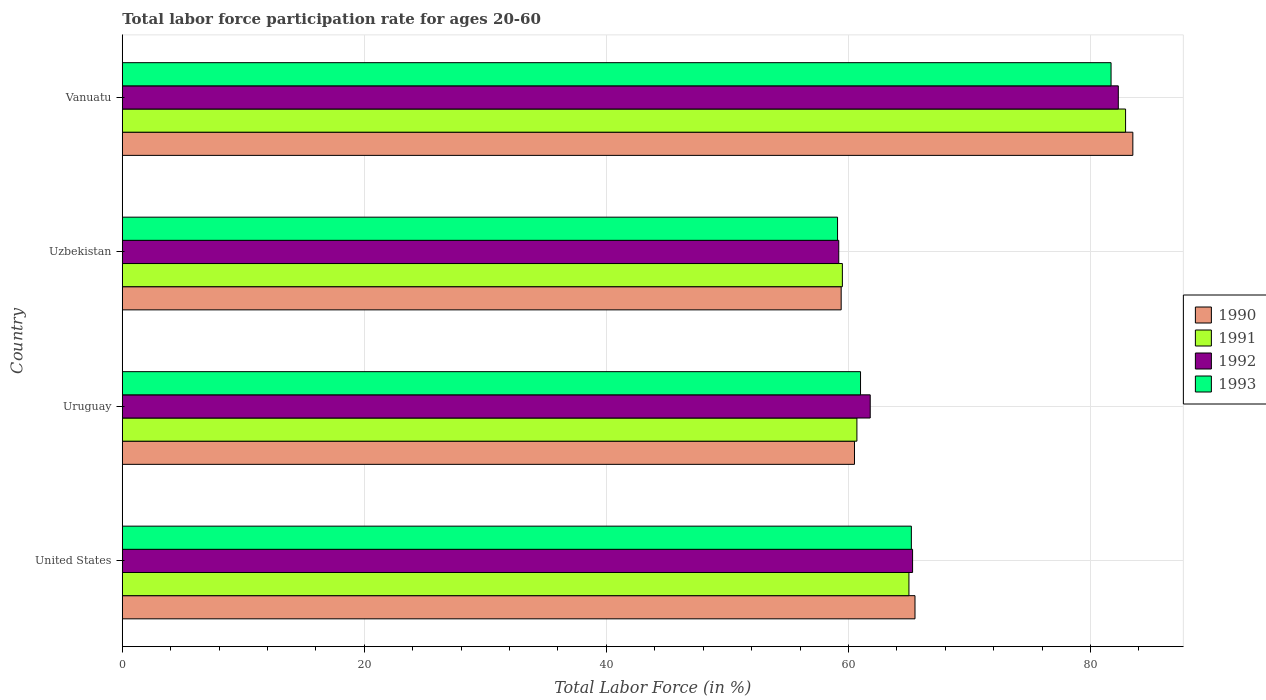How many different coloured bars are there?
Your answer should be compact. 4. Are the number of bars on each tick of the Y-axis equal?
Provide a short and direct response. Yes. How many bars are there on the 4th tick from the bottom?
Provide a short and direct response. 4. What is the label of the 3rd group of bars from the top?
Your answer should be compact. Uruguay. What is the labor force participation rate in 1992 in Vanuatu?
Your answer should be compact. 82.3. Across all countries, what is the maximum labor force participation rate in 1991?
Your answer should be very brief. 82.9. Across all countries, what is the minimum labor force participation rate in 1992?
Your answer should be very brief. 59.2. In which country was the labor force participation rate in 1991 maximum?
Your answer should be very brief. Vanuatu. In which country was the labor force participation rate in 1991 minimum?
Give a very brief answer. Uzbekistan. What is the total labor force participation rate in 1993 in the graph?
Your answer should be very brief. 267. What is the difference between the labor force participation rate in 1992 in United States and that in Uruguay?
Give a very brief answer. 3.5. What is the difference between the labor force participation rate in 1990 in Uzbekistan and the labor force participation rate in 1992 in Uruguay?
Your response must be concise. -2.4. What is the average labor force participation rate in 1991 per country?
Keep it short and to the point. 67.03. What is the difference between the labor force participation rate in 1993 and labor force participation rate in 1991 in Vanuatu?
Give a very brief answer. -1.2. In how many countries, is the labor force participation rate in 1993 greater than 36 %?
Give a very brief answer. 4. What is the ratio of the labor force participation rate in 1992 in United States to that in Vanuatu?
Offer a terse response. 0.79. What is the difference between the highest and the second highest labor force participation rate in 1993?
Provide a short and direct response. 16.5. What is the difference between the highest and the lowest labor force participation rate in 1990?
Make the answer very short. 24.1. Is it the case that in every country, the sum of the labor force participation rate in 1992 and labor force participation rate in 1993 is greater than the sum of labor force participation rate in 1990 and labor force participation rate in 1991?
Your answer should be very brief. No. What does the 2nd bar from the bottom in Uzbekistan represents?
Offer a very short reply. 1991. Is it the case that in every country, the sum of the labor force participation rate in 1993 and labor force participation rate in 1991 is greater than the labor force participation rate in 1990?
Give a very brief answer. Yes. How many bars are there?
Offer a very short reply. 16. How many countries are there in the graph?
Keep it short and to the point. 4. What is the difference between two consecutive major ticks on the X-axis?
Provide a succinct answer. 20. Are the values on the major ticks of X-axis written in scientific E-notation?
Your answer should be very brief. No. Does the graph contain grids?
Your answer should be very brief. Yes. How are the legend labels stacked?
Provide a short and direct response. Vertical. What is the title of the graph?
Your answer should be compact. Total labor force participation rate for ages 20-60. Does "1963" appear as one of the legend labels in the graph?
Ensure brevity in your answer.  No. What is the Total Labor Force (in %) of 1990 in United States?
Keep it short and to the point. 65.5. What is the Total Labor Force (in %) of 1992 in United States?
Ensure brevity in your answer.  65.3. What is the Total Labor Force (in %) of 1993 in United States?
Give a very brief answer. 65.2. What is the Total Labor Force (in %) in 1990 in Uruguay?
Make the answer very short. 60.5. What is the Total Labor Force (in %) in 1991 in Uruguay?
Give a very brief answer. 60.7. What is the Total Labor Force (in %) of 1992 in Uruguay?
Give a very brief answer. 61.8. What is the Total Labor Force (in %) of 1993 in Uruguay?
Your answer should be compact. 61. What is the Total Labor Force (in %) in 1990 in Uzbekistan?
Provide a succinct answer. 59.4. What is the Total Labor Force (in %) of 1991 in Uzbekistan?
Ensure brevity in your answer.  59.5. What is the Total Labor Force (in %) in 1992 in Uzbekistan?
Give a very brief answer. 59.2. What is the Total Labor Force (in %) in 1993 in Uzbekistan?
Provide a succinct answer. 59.1. What is the Total Labor Force (in %) in 1990 in Vanuatu?
Your answer should be compact. 83.5. What is the Total Labor Force (in %) in 1991 in Vanuatu?
Make the answer very short. 82.9. What is the Total Labor Force (in %) in 1992 in Vanuatu?
Provide a succinct answer. 82.3. What is the Total Labor Force (in %) in 1993 in Vanuatu?
Give a very brief answer. 81.7. Across all countries, what is the maximum Total Labor Force (in %) of 1990?
Your answer should be very brief. 83.5. Across all countries, what is the maximum Total Labor Force (in %) in 1991?
Provide a succinct answer. 82.9. Across all countries, what is the maximum Total Labor Force (in %) of 1992?
Your response must be concise. 82.3. Across all countries, what is the maximum Total Labor Force (in %) in 1993?
Make the answer very short. 81.7. Across all countries, what is the minimum Total Labor Force (in %) in 1990?
Offer a terse response. 59.4. Across all countries, what is the minimum Total Labor Force (in %) in 1991?
Ensure brevity in your answer.  59.5. Across all countries, what is the minimum Total Labor Force (in %) of 1992?
Offer a terse response. 59.2. Across all countries, what is the minimum Total Labor Force (in %) of 1993?
Your response must be concise. 59.1. What is the total Total Labor Force (in %) of 1990 in the graph?
Provide a short and direct response. 268.9. What is the total Total Labor Force (in %) of 1991 in the graph?
Offer a very short reply. 268.1. What is the total Total Labor Force (in %) of 1992 in the graph?
Provide a short and direct response. 268.6. What is the total Total Labor Force (in %) of 1993 in the graph?
Ensure brevity in your answer.  267. What is the difference between the Total Labor Force (in %) of 1993 in United States and that in Uruguay?
Give a very brief answer. 4.2. What is the difference between the Total Labor Force (in %) of 1991 in United States and that in Uzbekistan?
Keep it short and to the point. 5.5. What is the difference between the Total Labor Force (in %) of 1992 in United States and that in Uzbekistan?
Offer a very short reply. 6.1. What is the difference between the Total Labor Force (in %) in 1993 in United States and that in Uzbekistan?
Offer a very short reply. 6.1. What is the difference between the Total Labor Force (in %) of 1990 in United States and that in Vanuatu?
Offer a very short reply. -18. What is the difference between the Total Labor Force (in %) of 1991 in United States and that in Vanuatu?
Provide a short and direct response. -17.9. What is the difference between the Total Labor Force (in %) of 1993 in United States and that in Vanuatu?
Provide a succinct answer. -16.5. What is the difference between the Total Labor Force (in %) in 1990 in Uruguay and that in Uzbekistan?
Offer a very short reply. 1.1. What is the difference between the Total Labor Force (in %) in 1992 in Uruguay and that in Uzbekistan?
Provide a short and direct response. 2.6. What is the difference between the Total Labor Force (in %) in 1993 in Uruguay and that in Uzbekistan?
Offer a very short reply. 1.9. What is the difference between the Total Labor Force (in %) in 1990 in Uruguay and that in Vanuatu?
Your response must be concise. -23. What is the difference between the Total Labor Force (in %) of 1991 in Uruguay and that in Vanuatu?
Your answer should be compact. -22.2. What is the difference between the Total Labor Force (in %) in 1992 in Uruguay and that in Vanuatu?
Provide a succinct answer. -20.5. What is the difference between the Total Labor Force (in %) of 1993 in Uruguay and that in Vanuatu?
Offer a very short reply. -20.7. What is the difference between the Total Labor Force (in %) of 1990 in Uzbekistan and that in Vanuatu?
Keep it short and to the point. -24.1. What is the difference between the Total Labor Force (in %) of 1991 in Uzbekistan and that in Vanuatu?
Offer a very short reply. -23.4. What is the difference between the Total Labor Force (in %) in 1992 in Uzbekistan and that in Vanuatu?
Provide a succinct answer. -23.1. What is the difference between the Total Labor Force (in %) in 1993 in Uzbekistan and that in Vanuatu?
Your answer should be very brief. -22.6. What is the difference between the Total Labor Force (in %) in 1990 in United States and the Total Labor Force (in %) in 1992 in Uruguay?
Provide a short and direct response. 3.7. What is the difference between the Total Labor Force (in %) of 1991 in United States and the Total Labor Force (in %) of 1992 in Uruguay?
Offer a very short reply. 3.2. What is the difference between the Total Labor Force (in %) in 1991 in United States and the Total Labor Force (in %) in 1993 in Uruguay?
Your response must be concise. 4. What is the difference between the Total Labor Force (in %) of 1992 in United States and the Total Labor Force (in %) of 1993 in Uruguay?
Provide a short and direct response. 4.3. What is the difference between the Total Labor Force (in %) of 1990 in United States and the Total Labor Force (in %) of 1993 in Uzbekistan?
Provide a short and direct response. 6.4. What is the difference between the Total Labor Force (in %) of 1991 in United States and the Total Labor Force (in %) of 1992 in Uzbekistan?
Your answer should be very brief. 5.8. What is the difference between the Total Labor Force (in %) in 1990 in United States and the Total Labor Force (in %) in 1991 in Vanuatu?
Your response must be concise. -17.4. What is the difference between the Total Labor Force (in %) of 1990 in United States and the Total Labor Force (in %) of 1992 in Vanuatu?
Your response must be concise. -16.8. What is the difference between the Total Labor Force (in %) in 1990 in United States and the Total Labor Force (in %) in 1993 in Vanuatu?
Provide a succinct answer. -16.2. What is the difference between the Total Labor Force (in %) of 1991 in United States and the Total Labor Force (in %) of 1992 in Vanuatu?
Offer a very short reply. -17.3. What is the difference between the Total Labor Force (in %) in 1991 in United States and the Total Labor Force (in %) in 1993 in Vanuatu?
Offer a terse response. -16.7. What is the difference between the Total Labor Force (in %) in 1992 in United States and the Total Labor Force (in %) in 1993 in Vanuatu?
Provide a short and direct response. -16.4. What is the difference between the Total Labor Force (in %) in 1990 in Uruguay and the Total Labor Force (in %) in 1992 in Uzbekistan?
Ensure brevity in your answer.  1.3. What is the difference between the Total Labor Force (in %) of 1991 in Uruguay and the Total Labor Force (in %) of 1992 in Uzbekistan?
Provide a succinct answer. 1.5. What is the difference between the Total Labor Force (in %) in 1991 in Uruguay and the Total Labor Force (in %) in 1993 in Uzbekistan?
Give a very brief answer. 1.6. What is the difference between the Total Labor Force (in %) of 1992 in Uruguay and the Total Labor Force (in %) of 1993 in Uzbekistan?
Give a very brief answer. 2.7. What is the difference between the Total Labor Force (in %) of 1990 in Uruguay and the Total Labor Force (in %) of 1991 in Vanuatu?
Your answer should be compact. -22.4. What is the difference between the Total Labor Force (in %) in 1990 in Uruguay and the Total Labor Force (in %) in 1992 in Vanuatu?
Offer a terse response. -21.8. What is the difference between the Total Labor Force (in %) in 1990 in Uruguay and the Total Labor Force (in %) in 1993 in Vanuatu?
Ensure brevity in your answer.  -21.2. What is the difference between the Total Labor Force (in %) in 1991 in Uruguay and the Total Labor Force (in %) in 1992 in Vanuatu?
Provide a succinct answer. -21.6. What is the difference between the Total Labor Force (in %) in 1991 in Uruguay and the Total Labor Force (in %) in 1993 in Vanuatu?
Your answer should be compact. -21. What is the difference between the Total Labor Force (in %) of 1992 in Uruguay and the Total Labor Force (in %) of 1993 in Vanuatu?
Your response must be concise. -19.9. What is the difference between the Total Labor Force (in %) in 1990 in Uzbekistan and the Total Labor Force (in %) in 1991 in Vanuatu?
Provide a short and direct response. -23.5. What is the difference between the Total Labor Force (in %) in 1990 in Uzbekistan and the Total Labor Force (in %) in 1992 in Vanuatu?
Offer a very short reply. -22.9. What is the difference between the Total Labor Force (in %) in 1990 in Uzbekistan and the Total Labor Force (in %) in 1993 in Vanuatu?
Your answer should be very brief. -22.3. What is the difference between the Total Labor Force (in %) in 1991 in Uzbekistan and the Total Labor Force (in %) in 1992 in Vanuatu?
Provide a succinct answer. -22.8. What is the difference between the Total Labor Force (in %) in 1991 in Uzbekistan and the Total Labor Force (in %) in 1993 in Vanuatu?
Provide a short and direct response. -22.2. What is the difference between the Total Labor Force (in %) of 1992 in Uzbekistan and the Total Labor Force (in %) of 1993 in Vanuatu?
Your answer should be compact. -22.5. What is the average Total Labor Force (in %) of 1990 per country?
Provide a succinct answer. 67.22. What is the average Total Labor Force (in %) in 1991 per country?
Keep it short and to the point. 67.03. What is the average Total Labor Force (in %) of 1992 per country?
Offer a terse response. 67.15. What is the average Total Labor Force (in %) of 1993 per country?
Offer a very short reply. 66.75. What is the difference between the Total Labor Force (in %) of 1990 and Total Labor Force (in %) of 1993 in United States?
Your answer should be compact. 0.3. What is the difference between the Total Labor Force (in %) in 1991 and Total Labor Force (in %) in 1992 in United States?
Provide a succinct answer. -0.3. What is the difference between the Total Labor Force (in %) in 1990 and Total Labor Force (in %) in 1991 in Uruguay?
Make the answer very short. -0.2. What is the difference between the Total Labor Force (in %) of 1990 and Total Labor Force (in %) of 1993 in Uruguay?
Offer a very short reply. -0.5. What is the difference between the Total Labor Force (in %) in 1991 and Total Labor Force (in %) in 1993 in Uruguay?
Provide a succinct answer. -0.3. What is the difference between the Total Labor Force (in %) of 1992 and Total Labor Force (in %) of 1993 in Uruguay?
Your response must be concise. 0.8. What is the difference between the Total Labor Force (in %) in 1990 and Total Labor Force (in %) in 1993 in Uzbekistan?
Your answer should be compact. 0.3. What is the difference between the Total Labor Force (in %) in 1991 and Total Labor Force (in %) in 1992 in Uzbekistan?
Make the answer very short. 0.3. What is the difference between the Total Labor Force (in %) of 1992 and Total Labor Force (in %) of 1993 in Uzbekistan?
Your response must be concise. 0.1. What is the difference between the Total Labor Force (in %) of 1990 and Total Labor Force (in %) of 1993 in Vanuatu?
Your answer should be compact. 1.8. What is the difference between the Total Labor Force (in %) in 1991 and Total Labor Force (in %) in 1992 in Vanuatu?
Your answer should be very brief. 0.6. What is the difference between the Total Labor Force (in %) in 1992 and Total Labor Force (in %) in 1993 in Vanuatu?
Provide a short and direct response. 0.6. What is the ratio of the Total Labor Force (in %) of 1990 in United States to that in Uruguay?
Your answer should be compact. 1.08. What is the ratio of the Total Labor Force (in %) of 1991 in United States to that in Uruguay?
Keep it short and to the point. 1.07. What is the ratio of the Total Labor Force (in %) of 1992 in United States to that in Uruguay?
Give a very brief answer. 1.06. What is the ratio of the Total Labor Force (in %) in 1993 in United States to that in Uruguay?
Your answer should be compact. 1.07. What is the ratio of the Total Labor Force (in %) of 1990 in United States to that in Uzbekistan?
Your answer should be very brief. 1.1. What is the ratio of the Total Labor Force (in %) in 1991 in United States to that in Uzbekistan?
Ensure brevity in your answer.  1.09. What is the ratio of the Total Labor Force (in %) in 1992 in United States to that in Uzbekistan?
Make the answer very short. 1.1. What is the ratio of the Total Labor Force (in %) of 1993 in United States to that in Uzbekistan?
Offer a very short reply. 1.1. What is the ratio of the Total Labor Force (in %) in 1990 in United States to that in Vanuatu?
Ensure brevity in your answer.  0.78. What is the ratio of the Total Labor Force (in %) in 1991 in United States to that in Vanuatu?
Keep it short and to the point. 0.78. What is the ratio of the Total Labor Force (in %) in 1992 in United States to that in Vanuatu?
Give a very brief answer. 0.79. What is the ratio of the Total Labor Force (in %) of 1993 in United States to that in Vanuatu?
Provide a succinct answer. 0.8. What is the ratio of the Total Labor Force (in %) in 1990 in Uruguay to that in Uzbekistan?
Ensure brevity in your answer.  1.02. What is the ratio of the Total Labor Force (in %) of 1991 in Uruguay to that in Uzbekistan?
Your answer should be compact. 1.02. What is the ratio of the Total Labor Force (in %) of 1992 in Uruguay to that in Uzbekistan?
Offer a terse response. 1.04. What is the ratio of the Total Labor Force (in %) of 1993 in Uruguay to that in Uzbekistan?
Your answer should be very brief. 1.03. What is the ratio of the Total Labor Force (in %) in 1990 in Uruguay to that in Vanuatu?
Make the answer very short. 0.72. What is the ratio of the Total Labor Force (in %) of 1991 in Uruguay to that in Vanuatu?
Give a very brief answer. 0.73. What is the ratio of the Total Labor Force (in %) in 1992 in Uruguay to that in Vanuatu?
Provide a succinct answer. 0.75. What is the ratio of the Total Labor Force (in %) of 1993 in Uruguay to that in Vanuatu?
Provide a succinct answer. 0.75. What is the ratio of the Total Labor Force (in %) in 1990 in Uzbekistan to that in Vanuatu?
Offer a terse response. 0.71. What is the ratio of the Total Labor Force (in %) of 1991 in Uzbekistan to that in Vanuatu?
Ensure brevity in your answer.  0.72. What is the ratio of the Total Labor Force (in %) of 1992 in Uzbekistan to that in Vanuatu?
Provide a succinct answer. 0.72. What is the ratio of the Total Labor Force (in %) in 1993 in Uzbekistan to that in Vanuatu?
Ensure brevity in your answer.  0.72. What is the difference between the highest and the second highest Total Labor Force (in %) in 1990?
Your response must be concise. 18. What is the difference between the highest and the lowest Total Labor Force (in %) of 1990?
Offer a very short reply. 24.1. What is the difference between the highest and the lowest Total Labor Force (in %) of 1991?
Give a very brief answer. 23.4. What is the difference between the highest and the lowest Total Labor Force (in %) of 1992?
Your answer should be compact. 23.1. What is the difference between the highest and the lowest Total Labor Force (in %) in 1993?
Ensure brevity in your answer.  22.6. 